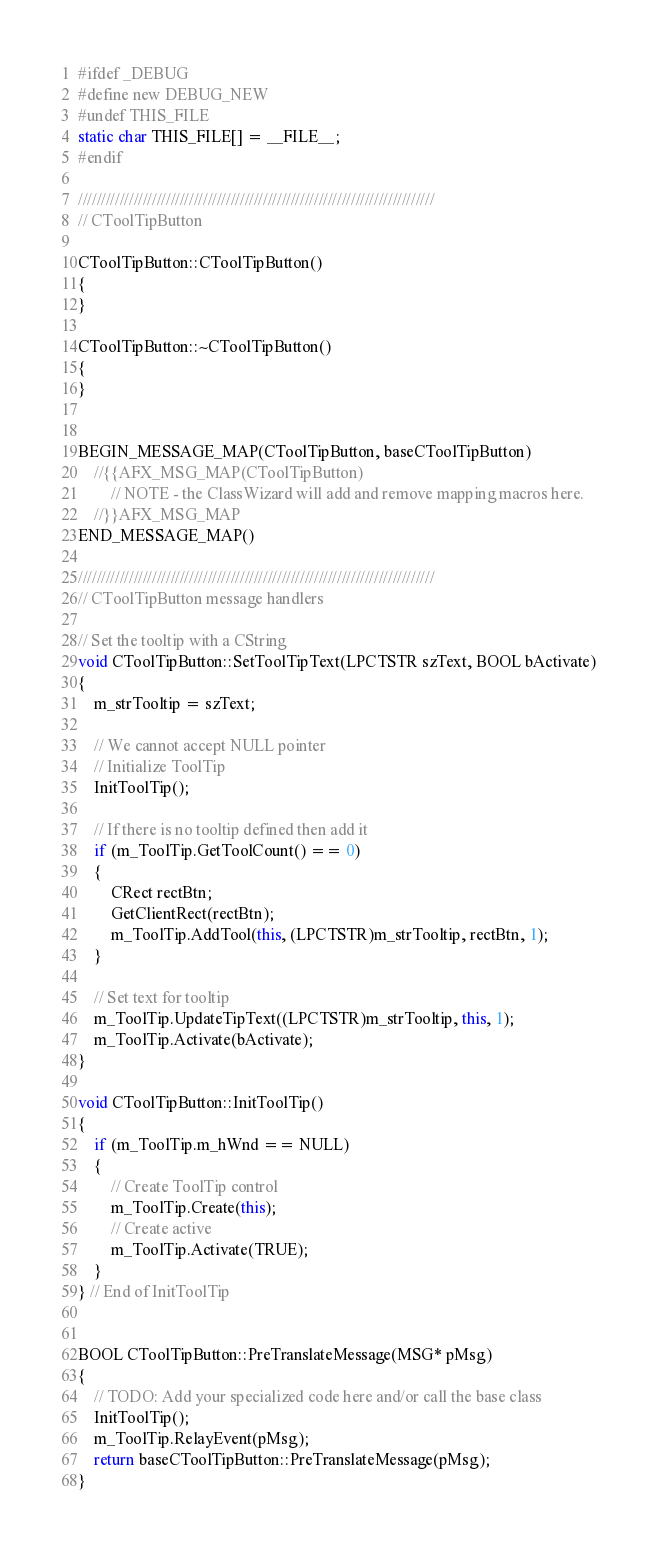Convert code to text. <code><loc_0><loc_0><loc_500><loc_500><_C++_>
#ifdef _DEBUG
#define new DEBUG_NEW
#undef THIS_FILE
static char THIS_FILE[] = __FILE__;
#endif

/////////////////////////////////////////////////////////////////////////////
// CToolTipButton

CToolTipButton::CToolTipButton()
{
}

CToolTipButton::~CToolTipButton()
{
}


BEGIN_MESSAGE_MAP(CToolTipButton, baseCToolTipButton)
	//{{AFX_MSG_MAP(CToolTipButton)
		// NOTE - the ClassWizard will add and remove mapping macros here.
	//}}AFX_MSG_MAP
END_MESSAGE_MAP()

/////////////////////////////////////////////////////////////////////////////
// CToolTipButton message handlers

// Set the tooltip with a CString
void CToolTipButton::SetToolTipText(LPCTSTR szText, BOOL bActivate)
{
	m_strTooltip = szText;

	// We cannot accept NULL pointer
	// Initialize ToolTip
	InitToolTip();

	// If there is no tooltip defined then add it
	if (m_ToolTip.GetToolCount() == 0)
	{
		CRect rectBtn; 
		GetClientRect(rectBtn);
		m_ToolTip.AddTool(this, (LPCTSTR)m_strTooltip, rectBtn, 1);
	}

	// Set text for tooltip
	m_ToolTip.UpdateTipText((LPCTSTR)m_strTooltip, this, 1);
	m_ToolTip.Activate(bActivate);
}

void CToolTipButton::InitToolTip()
{
	if (m_ToolTip.m_hWnd == NULL)
	{
		// Create ToolTip control
		m_ToolTip.Create(this);
		// Create active
		m_ToolTip.Activate(TRUE);
	}
} // End of InitToolTip


BOOL CToolTipButton::PreTranslateMessage(MSG* pMsg) 
{
	// TODO: Add your specialized code here and/or call the base class
	InitToolTip();
	m_ToolTip.RelayEvent(pMsg);		
	return baseCToolTipButton::PreTranslateMessage(pMsg);
}


</code> 